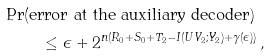Convert formula to latex. <formula><loc_0><loc_0><loc_500><loc_500>\Pr & ( \text {error at the auxiliary decoder} ) \\ & \quad \leq \epsilon + 2 ^ { n ( R _ { 0 } + S _ { 0 } + T _ { 2 } - I ( U V _ { 2 } ; Y _ { 2 } ) + \gamma ( \epsilon ) ) } \, ,</formula> 